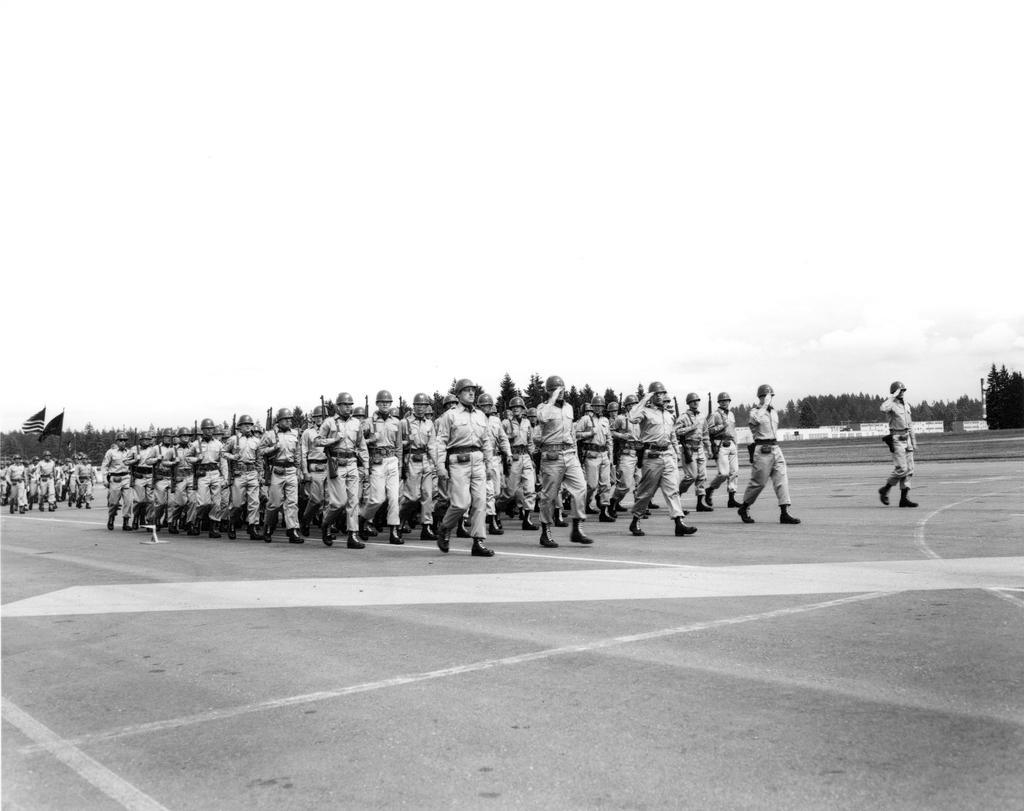In one or two sentences, can you explain what this image depicts? There are people walking on the road. We can see flags. In the background we can see trees, wall and sky. 